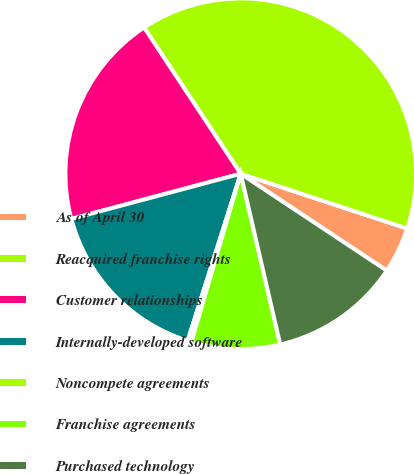Convert chart. <chart><loc_0><loc_0><loc_500><loc_500><pie_chart><fcel>As of April 30<fcel>Reacquired franchise rights<fcel>Customer relationships<fcel>Internally-developed software<fcel>Noncompete agreements<fcel>Franchise agreements<fcel>Purchased technology<nl><fcel>4.26%<fcel>39.36%<fcel>19.86%<fcel>15.96%<fcel>0.35%<fcel>8.16%<fcel>12.06%<nl></chart> 